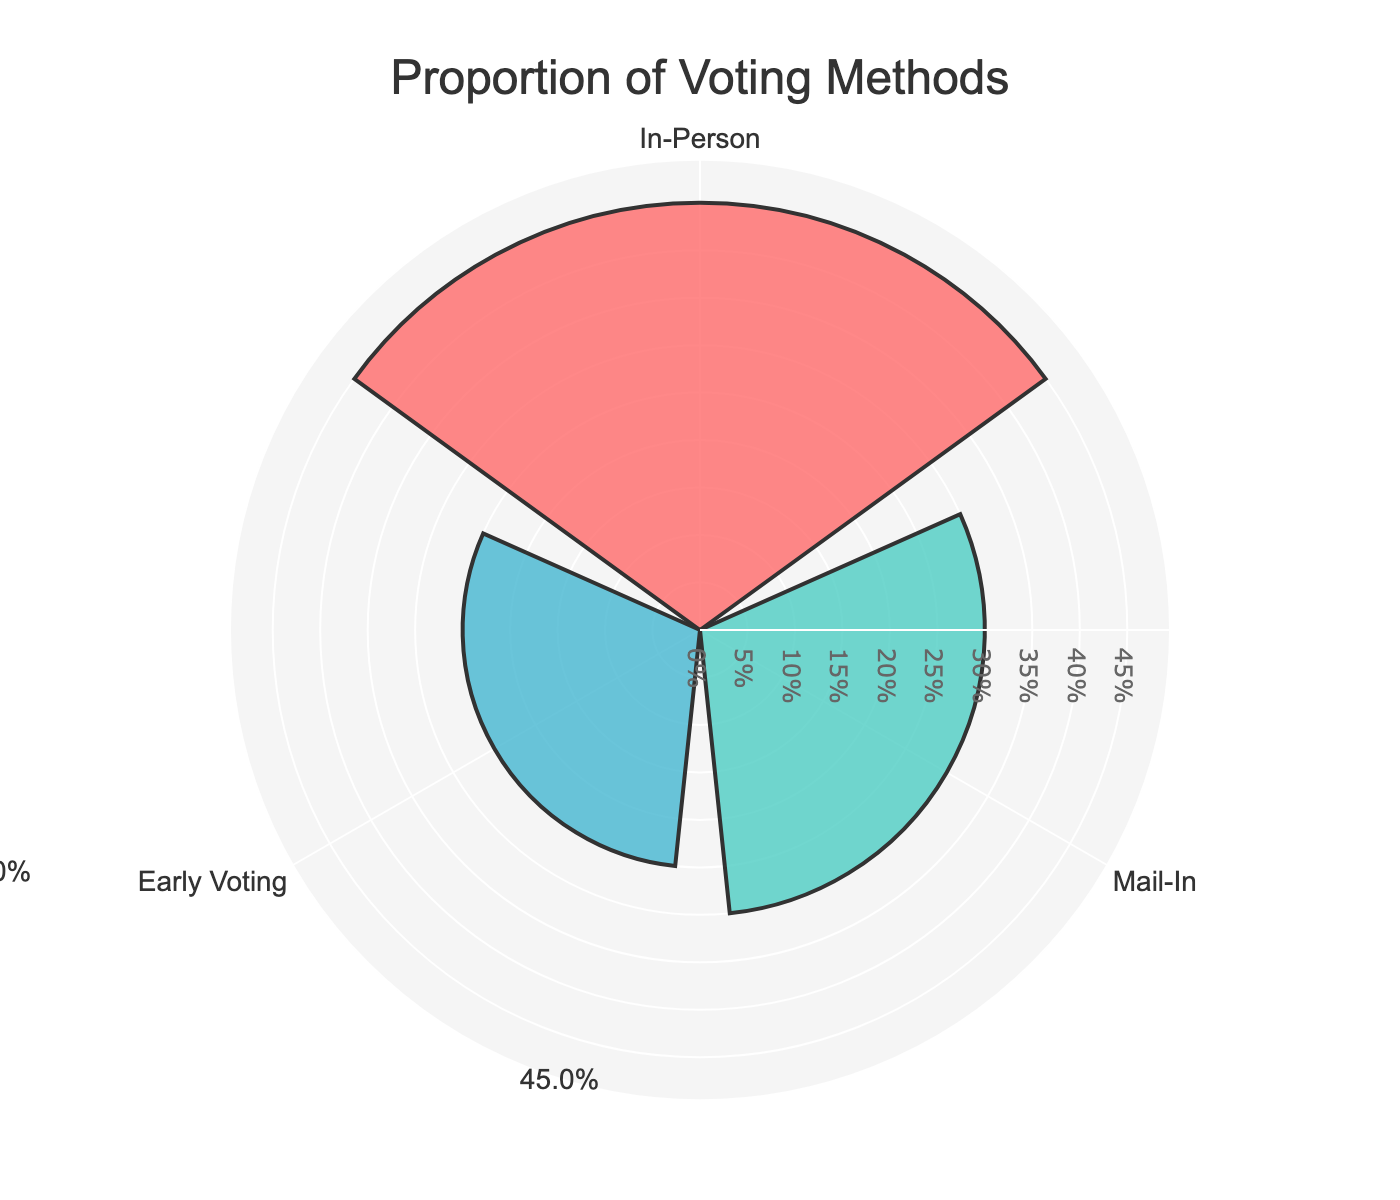What is the title of the chart? The title is centered at the top of the figure and provides an overview of the chart's contents. Reading it helps us understand the topic of the chart.
Answer: "Proportion of Voting Methods" What are the different voting methods shown in the chart? The rose chart uses labels on the angular axis to show the different voting methods. Reading these labels, we identify the voting methods.
Answer: In-Person, Mail-In, Early Voting Which voting method has the highest proportion? By comparing the radial lengths of the bars, the longest bar indicates the highest proportion.
Answer: In-Person What proportion of votes is represented by Early Voting? The value is found directly from the text annotation on the Early Voting bar or by reading the radial length.
Answer: 25% What is the combined proportion of Mail-In and Early Voting? Add the proportions of Mail-In (30%) and Early Voting (25%): 0.30 + 0.25 = 0.55
Answer: 55% Which voting method has the smallest proportion, and what is that proportion? The shortest bar indicates the smallest proportion. By reading its length or annotation, we get the value.
Answer: Early Voting, 25% How does the proportion of Mail-In voting compare to In-Person voting? Compare the proportions of Mail-In (30%) and In-Person (45%). Since 30% is less than 45%, Mail-In is lower.
Answer: Mail-In is less than In-Person What is the difference in proportion between In-Person and Early Voting? Subtract the Early Voting proportion (25%) from the In-Person proportion (45%): 0.45 - 0.25 = 0.20
Answer: 20% What does the color coding in the chart represent? The chart assigns different colors to each voting method to distinguish them visually.
Answer: Different voting methods If one wants to focus on the method with the second highest proportion, which method should they focus on? The second highest proportion is indicated by the second longest bar. Comparing the lengths, we find it is Mail-In with 30%.
Answer: Mail-In 